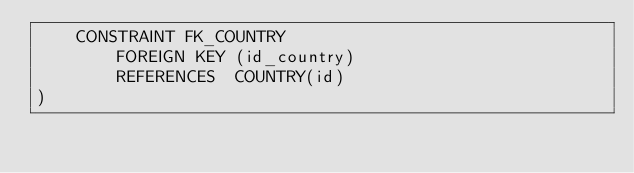<code> <loc_0><loc_0><loc_500><loc_500><_SQL_>    CONSTRAINT FK_COUNTRY
        FOREIGN KEY (id_country)
        REFERENCES  COUNTRY(id)
)</code> 